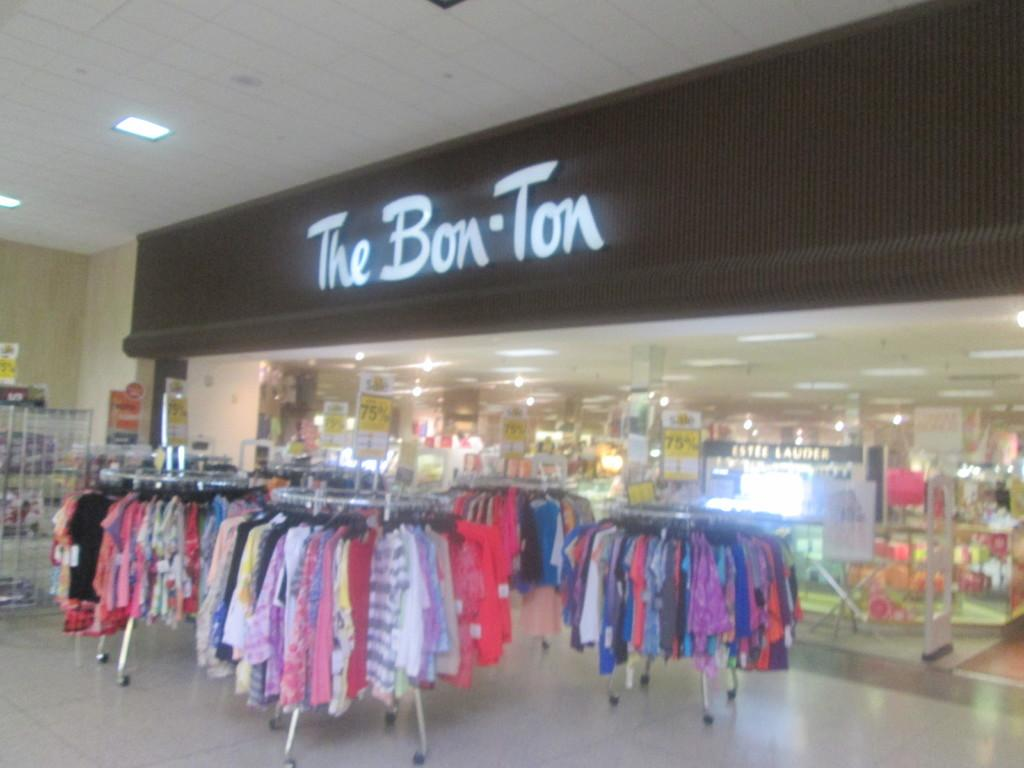What type of establishment is depicted in the image? There is a shop in the image. What can be seen on the floor in front of the shop? Hangers are kept on the floor in front of the shop. What are the hangers used for in the image? Clothes are hung on the hangers. What is visible on the left side of the image? There is a wall on the left side of the image. What type of grain can be seen growing on the wall in the image? There is no grain visible in the image; the wall is a solid structure. 